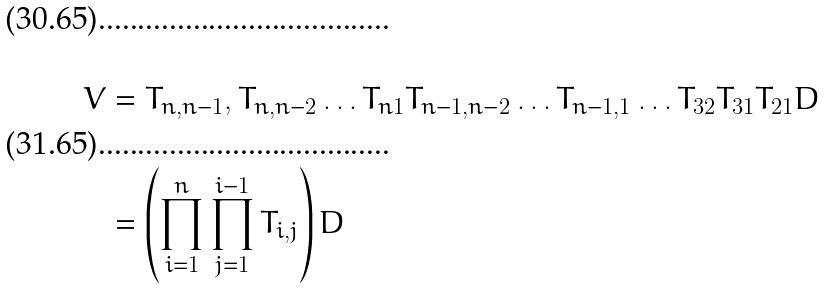Convert formula to latex. <formula><loc_0><loc_0><loc_500><loc_500>V & = T _ { n , n - 1 } , T _ { n , n - 2 } \dots T _ { n 1 } T _ { n - 1 , n - 2 } \dots T _ { n - 1 , 1 } \dots T _ { 3 2 } T _ { 3 1 } T _ { 2 1 } D \\ & = \left ( \prod ^ { n } _ { i = 1 } \prod ^ { i - 1 } _ { j = 1 } T _ { i , j } \right ) D</formula> 